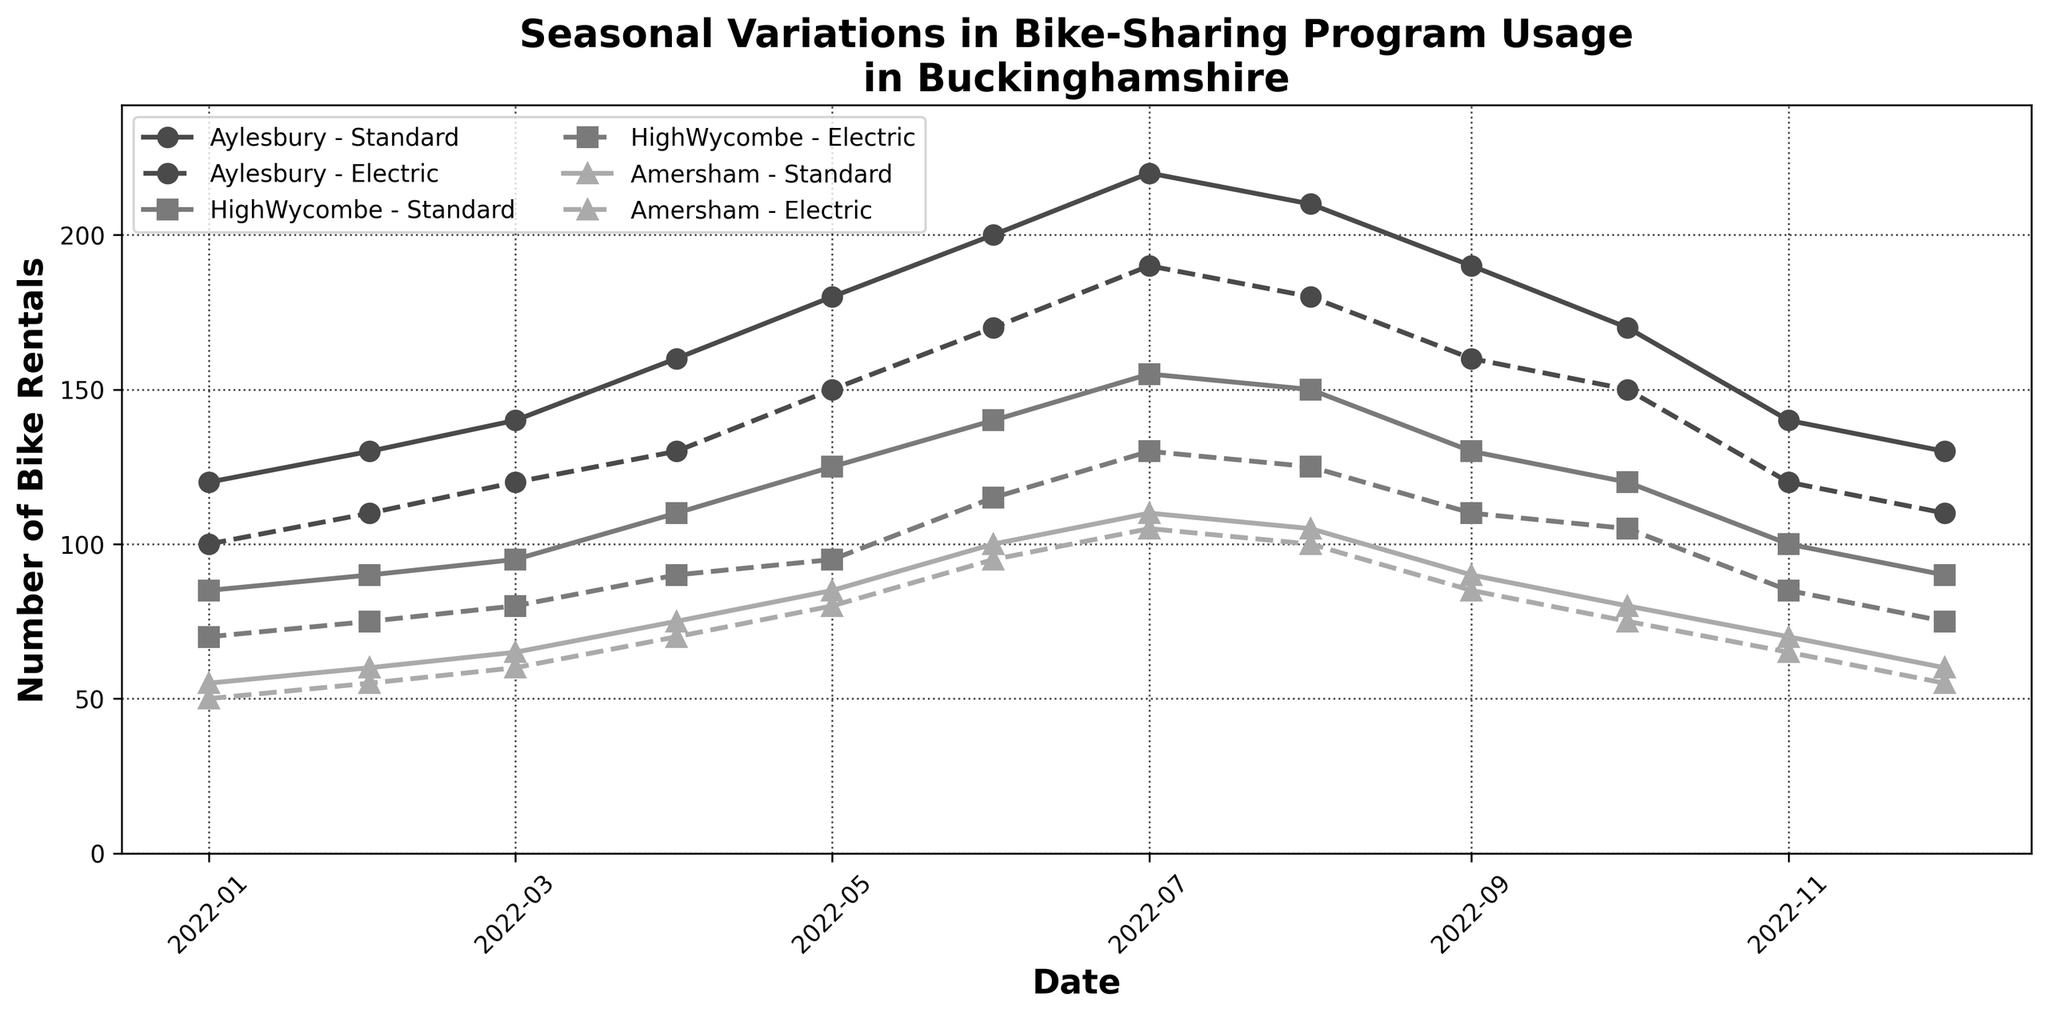What is the title of the figure? The title of the figure is usually placed at the top of the chart and is rendered in a bold, larger font. In this case, the title is: "Seasonal Variations in Bike-Sharing Program Usage in Buckinghamshire".
Answer: Seasonal Variations in Bike-Sharing Program Usage in Buckinghamshire Which city had the highest number of bike rentals in July for standard bikes? To find the highest number of bike rentals in July for standard bikes, locate the line for Aylesbury-Standard, HighWycombe-Standard, and Amersham-Standard in the month of July. Aylesbury had 220 rentals, which is the highest among the three.
Answer: Aylesbury From April to August, which type of bike had consistently higher usage in HighWycombe? Check the lines for HighWycombe-Standard (solid) and HighWycombe-Electric (dashed) from April to August. The standard bike usage is always higher than electric bike usage in these months.
Answer: Standard What’s the peak month for electric bike usage in Amersham? Look for the highest point on the dashed line representing Amersham-Electric throughout the months on the x-axis. The peak is in July with 105 rentals.
Answer: July How many times did Aylesbury have electric bike rentals greater than 150 in a month? Look for the dashed line representing Aylesbury-Electric and count the instances where the line is above 150 on the y-axis. This occurred in June, July, and August, totaling 3 times.
Answer: 3 times Compare the increase in standard bike rentals from January to July for Aylesbury. Subtract the number of standard bike rentals in January from the number in July for Aylesbury. In January, there were 120 rentals, and in July, there were 220 rentals. The increase is 220 - 120 = 100.
Answer: 100 During which month did HighWycombe see a noticeable drop in both standard and electric bike rentals? Observe the lines for HighWycombe-Standard and HighWycombe-Electric and find the month where both lines drop noticeably. This drop occurs in October, where both bike types show a decline compared to September.
Answer: October Which bike type had consistently fewer rentals in Amersham compared to HighWycombe in the given time period? Compare the dashed and solid lines for both Amersham and HighWycombe throughout the entire time period. For both Standard and Electric bikes, Amersham consistently has fewer rentals compared to HighWycombe.
Answer: Both Was there any month where the bike rentals for Aylesbury-Electric bikes were the same as those in January? If so, identify the month. Compare the electric bike rentals for Aylesbury each month to the January figure (100). Find the month where the value is the same. Both January and December have 100 rentals.
Answer: December 